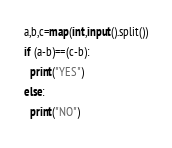<code> <loc_0><loc_0><loc_500><loc_500><_Python_>a,b,c=map(int,input().split())
if (a-b)==(c-b):
  print("YES")
else:
  print("NO")</code> 